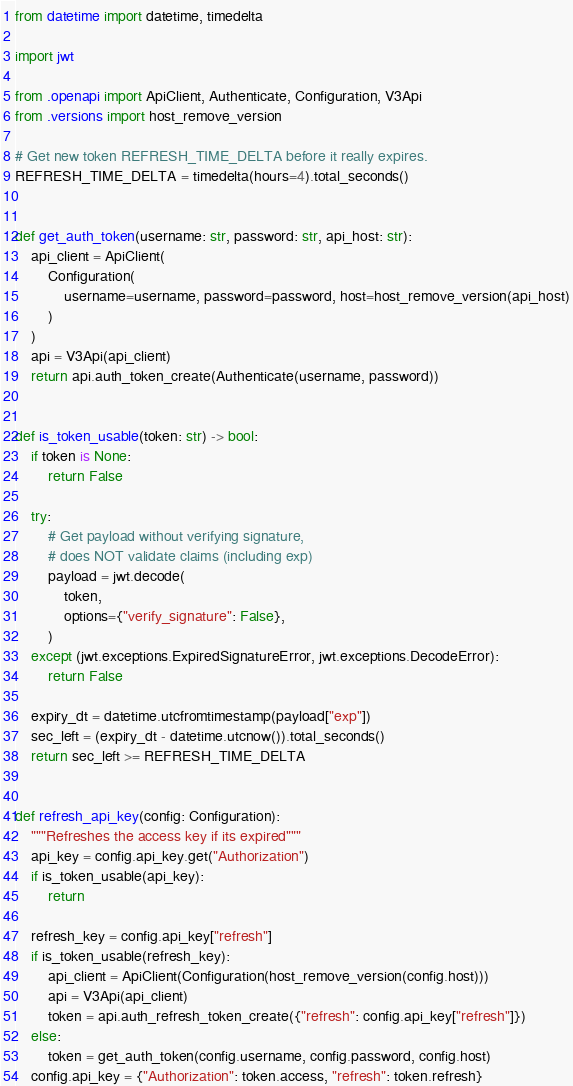Convert code to text. <code><loc_0><loc_0><loc_500><loc_500><_Python_>from datetime import datetime, timedelta

import jwt

from .openapi import ApiClient, Authenticate, Configuration, V3Api
from .versions import host_remove_version

# Get new token REFRESH_TIME_DELTA before it really expires.
REFRESH_TIME_DELTA = timedelta(hours=4).total_seconds()


def get_auth_token(username: str, password: str, api_host: str):
    api_client = ApiClient(
        Configuration(
            username=username, password=password, host=host_remove_version(api_host)
        )
    )
    api = V3Api(api_client)
    return api.auth_token_create(Authenticate(username, password))


def is_token_usable(token: str) -> bool:
    if token is None:
        return False

    try:
        # Get payload without verifying signature,
        # does NOT validate claims (including exp)
        payload = jwt.decode(
            token,
            options={"verify_signature": False},
        )
    except (jwt.exceptions.ExpiredSignatureError, jwt.exceptions.DecodeError):
        return False

    expiry_dt = datetime.utcfromtimestamp(payload["exp"])
    sec_left = (expiry_dt - datetime.utcnow()).total_seconds()
    return sec_left >= REFRESH_TIME_DELTA


def refresh_api_key(config: Configuration):
    """Refreshes the access key if its expired"""
    api_key = config.api_key.get("Authorization")
    if is_token_usable(api_key):
        return

    refresh_key = config.api_key["refresh"]
    if is_token_usable(refresh_key):
        api_client = ApiClient(Configuration(host_remove_version(config.host)))
        api = V3Api(api_client)
        token = api.auth_refresh_token_create({"refresh": config.api_key["refresh"]})
    else:
        token = get_auth_token(config.username, config.password, config.host)
    config.api_key = {"Authorization": token.access, "refresh": token.refresh}
</code> 